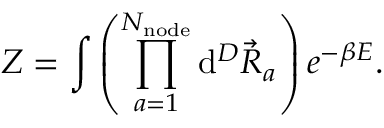Convert formula to latex. <formula><loc_0><loc_0><loc_500><loc_500>Z = \int { \left ( \prod _ { a = 1 } ^ { N _ { n o d e } } { d ^ { D } \vec { R } _ { a } } \right ) e ^ { - \beta E } } .</formula> 